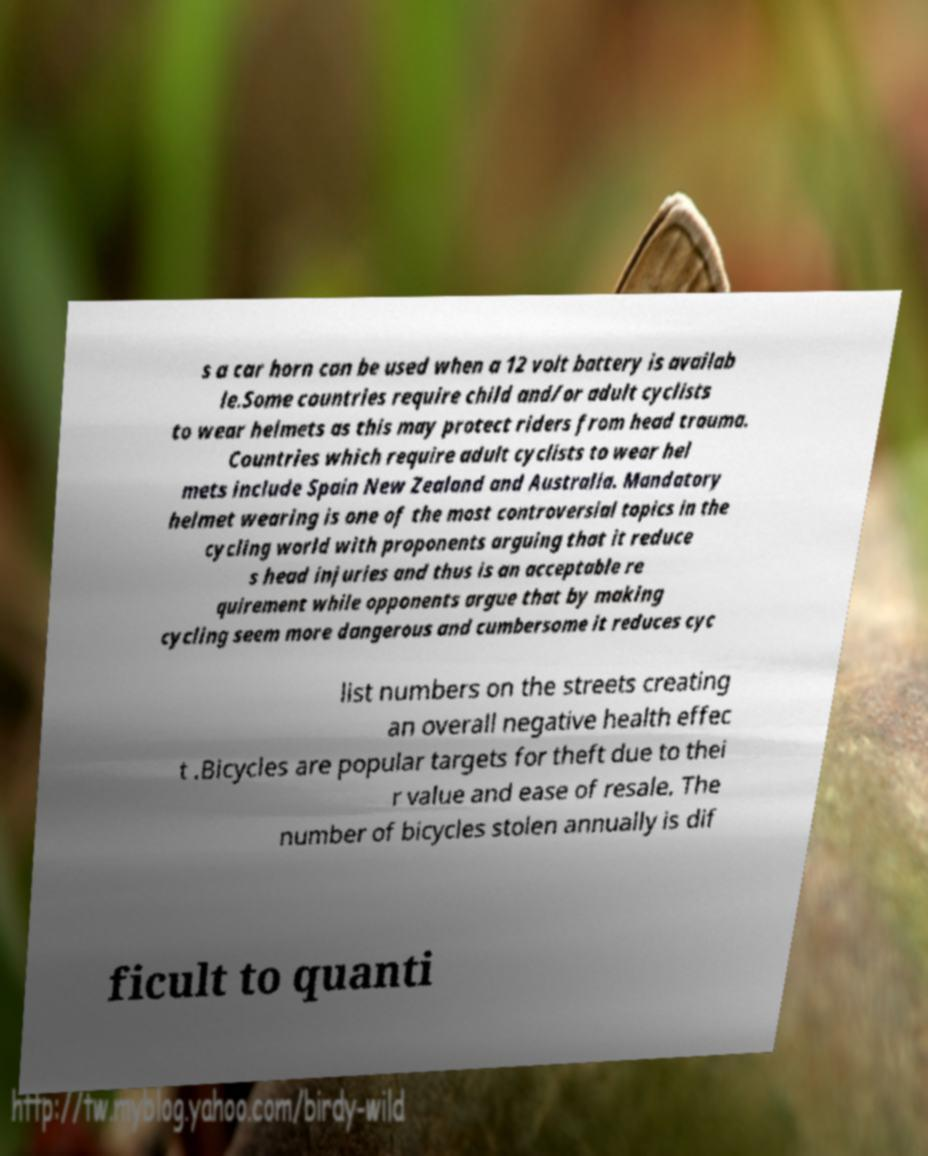Please read and relay the text visible in this image. What does it say? s a car horn can be used when a 12 volt battery is availab le.Some countries require child and/or adult cyclists to wear helmets as this may protect riders from head trauma. Countries which require adult cyclists to wear hel mets include Spain New Zealand and Australia. Mandatory helmet wearing is one of the most controversial topics in the cycling world with proponents arguing that it reduce s head injuries and thus is an acceptable re quirement while opponents argue that by making cycling seem more dangerous and cumbersome it reduces cyc list numbers on the streets creating an overall negative health effec t .Bicycles are popular targets for theft due to thei r value and ease of resale. The number of bicycles stolen annually is dif ficult to quanti 